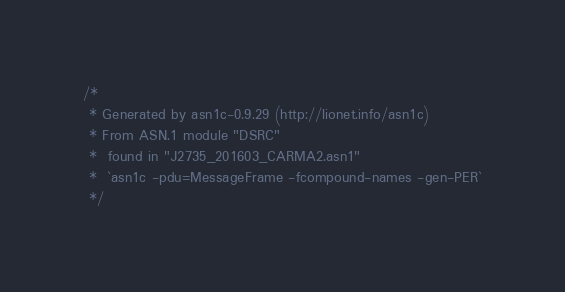Convert code to text. <code><loc_0><loc_0><loc_500><loc_500><_C_>/*
 * Generated by asn1c-0.9.29 (http://lionet.info/asn1c)
 * From ASN.1 module "DSRC"
 * 	found in "J2735_201603_CARMA2.asn1"
 * 	`asn1c -pdu=MessageFrame -fcompound-names -gen-PER`
 */
</code> 